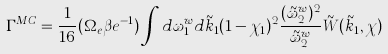<formula> <loc_0><loc_0><loc_500><loc_500>\Gamma ^ { M C } = \frac { 1 } { 1 6 } ( \Omega _ { e } \beta { e } ^ { - 1 } ) \int d \omega _ { 1 } ^ { w } d \tilde { k } _ { 1 } ( 1 - \chi _ { 1 } ) ^ { 2 } \frac { ( \tilde { \omega } _ { 2 } ^ { w } ) ^ { 2 } } { \tilde { \omega } _ { 2 } ^ { w } } \tilde { W } ( \tilde { k } _ { 1 } , \chi )</formula> 